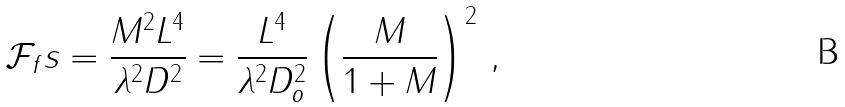<formula> <loc_0><loc_0><loc_500><loc_500>\mathcal { F } _ { f } s = \frac { M ^ { 2 } L ^ { 4 } } { \lambda ^ { 2 } D ^ { 2 } } = \frac { L ^ { 4 } } { \lambda ^ { 2 } D _ { o } ^ { 2 } } \left ( \frac { M } { 1 + M } \right ) ^ { 2 } \, ,</formula> 